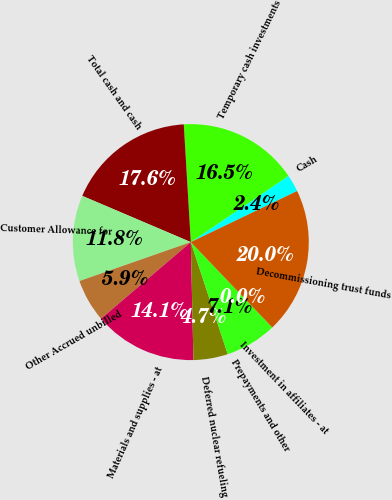Convert chart to OTSL. <chart><loc_0><loc_0><loc_500><loc_500><pie_chart><fcel>Cash<fcel>Temporary cash investments<fcel>Total cash and cash<fcel>Customer Allowance for<fcel>Other Accrued unbilled<fcel>Materials and supplies - at<fcel>Deferred nuclear refueling<fcel>Prepayments and other<fcel>Investment in affiliates - at<fcel>Decommissioning trust funds<nl><fcel>2.36%<fcel>16.46%<fcel>17.64%<fcel>11.76%<fcel>5.89%<fcel>14.11%<fcel>4.71%<fcel>7.06%<fcel>0.01%<fcel>19.99%<nl></chart> 